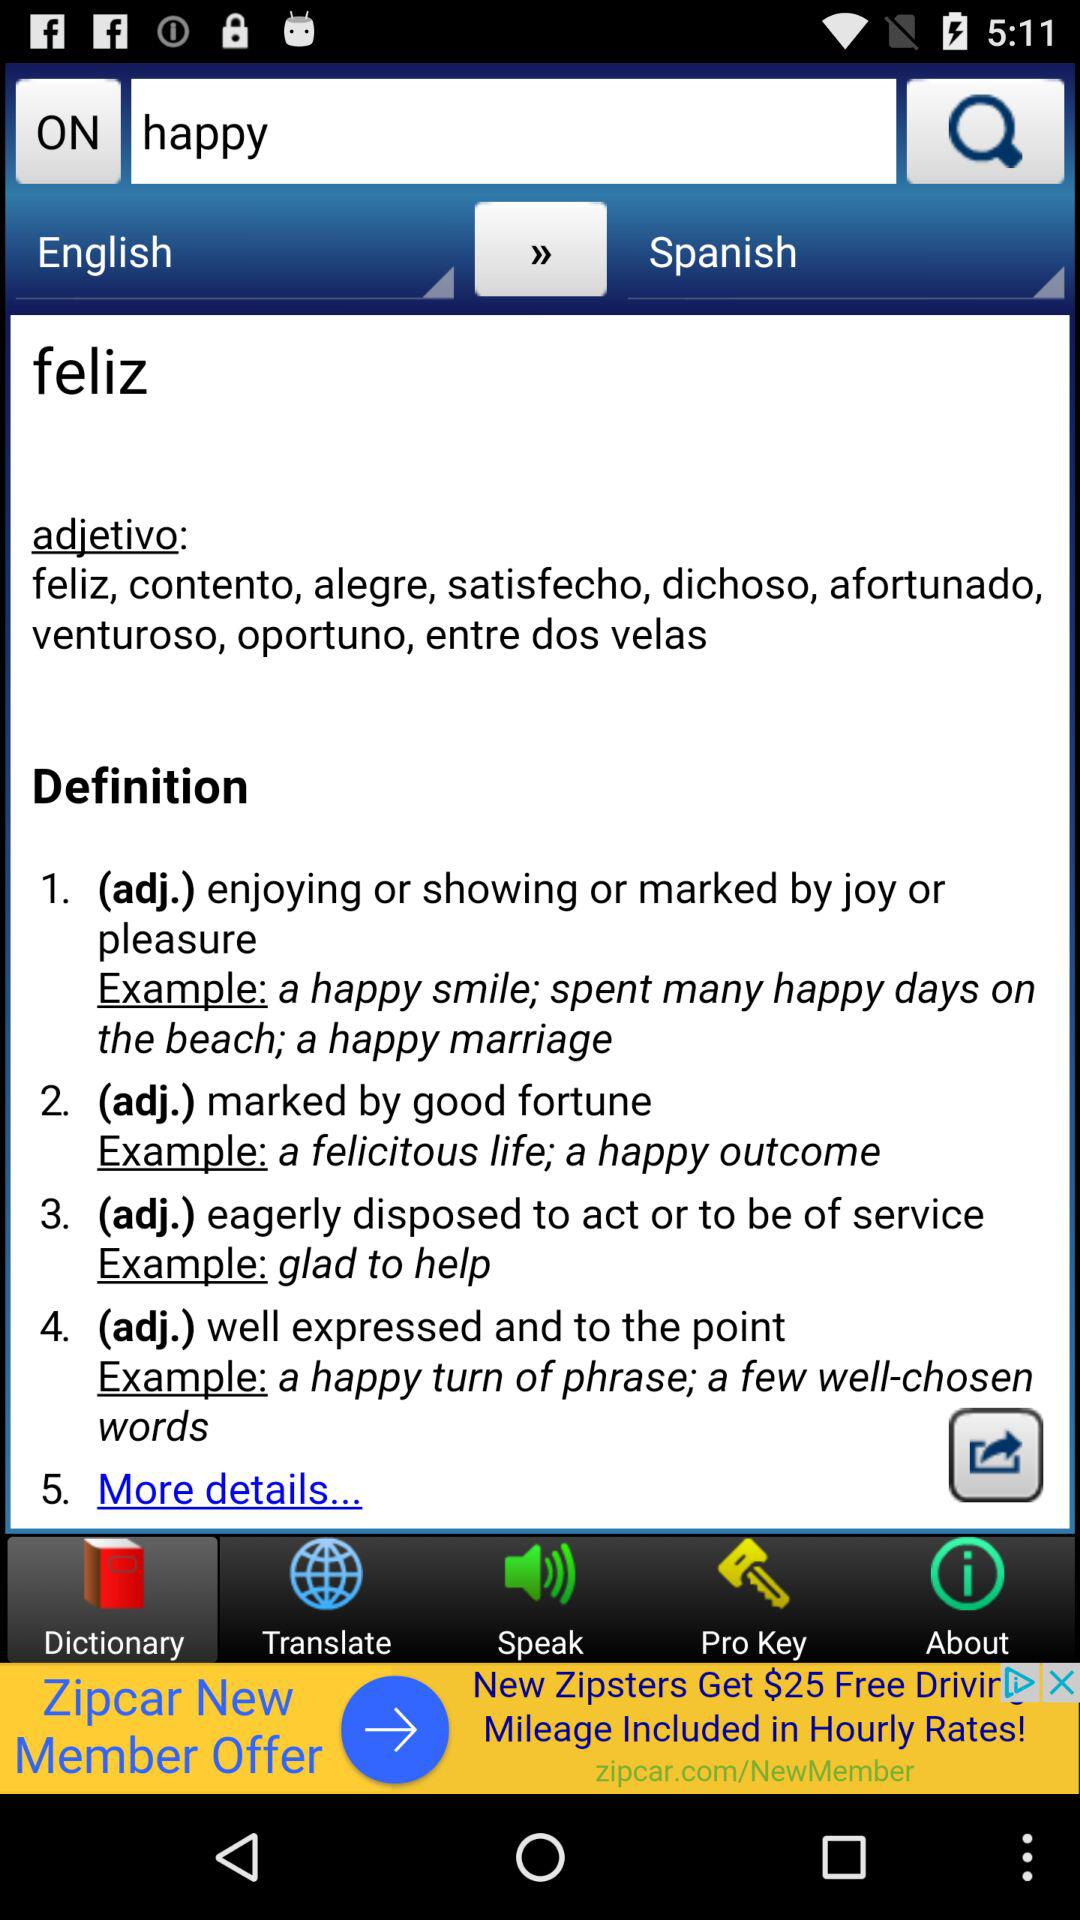Which language does the word translate into? The word translate into Spanish language. 